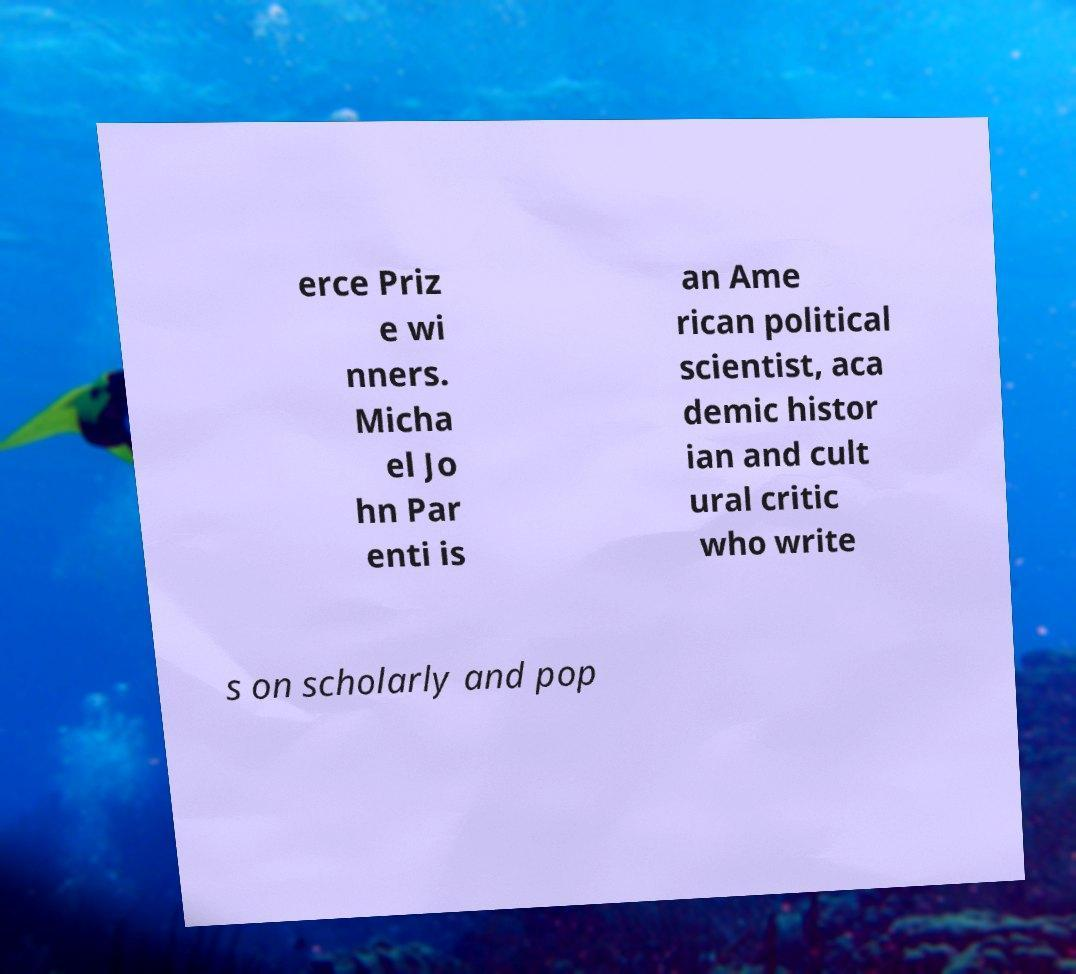Can you read and provide the text displayed in the image?This photo seems to have some interesting text. Can you extract and type it out for me? erce Priz e wi nners. Micha el Jo hn Par enti is an Ame rican political scientist, aca demic histor ian and cult ural critic who write s on scholarly and pop 